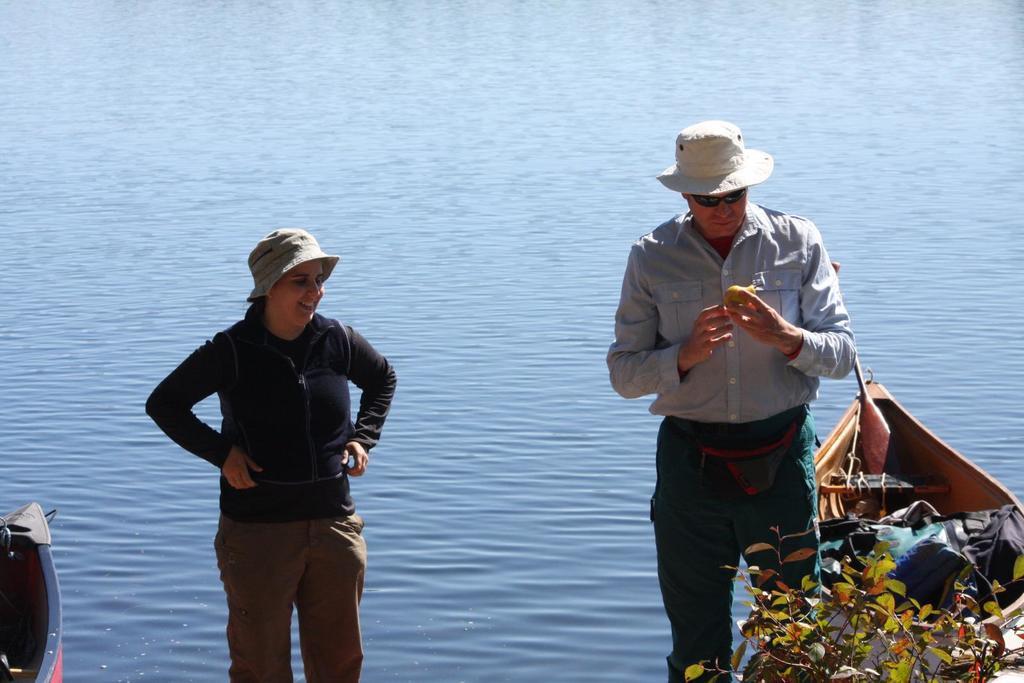In one or two sentences, can you explain what this image depicts? In this picture, there is a woman towards the left. She is wearing a black jacket and cream trousers. Towards the right, there is a man wearing a grey shirt and black trousers. Towards the left and right, there are boats on the river. In the background, there is water. 